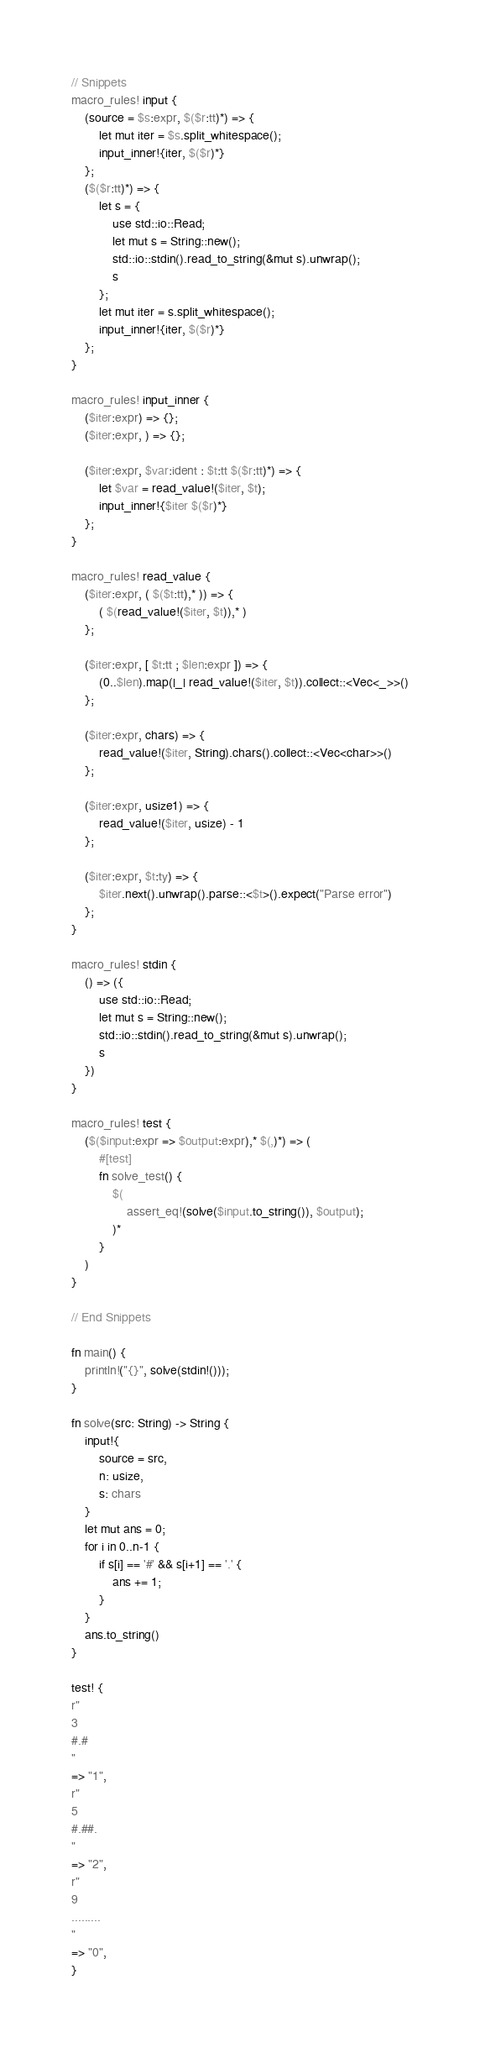Convert code to text. <code><loc_0><loc_0><loc_500><loc_500><_Rust_>// Snippets
macro_rules! input {
    (source = $s:expr, $($r:tt)*) => {
        let mut iter = $s.split_whitespace();
        input_inner!{iter, $($r)*}
    };
    ($($r:tt)*) => {
        let s = {
            use std::io::Read;
            let mut s = String::new();
            std::io::stdin().read_to_string(&mut s).unwrap();
            s
        };
        let mut iter = s.split_whitespace();
        input_inner!{iter, $($r)*}
    };
}

macro_rules! input_inner {
    ($iter:expr) => {};
    ($iter:expr, ) => {};

    ($iter:expr, $var:ident : $t:tt $($r:tt)*) => {
        let $var = read_value!($iter, $t);
        input_inner!{$iter $($r)*}
    };
}

macro_rules! read_value {
    ($iter:expr, ( $($t:tt),* )) => {
        ( $(read_value!($iter, $t)),* )
    };

    ($iter:expr, [ $t:tt ; $len:expr ]) => {
        (0..$len).map(|_| read_value!($iter, $t)).collect::<Vec<_>>()
    };

    ($iter:expr, chars) => {
        read_value!($iter, String).chars().collect::<Vec<char>>()
    };

    ($iter:expr, usize1) => {
        read_value!($iter, usize) - 1
    };

    ($iter:expr, $t:ty) => {
        $iter.next().unwrap().parse::<$t>().expect("Parse error")
    };
}

macro_rules! stdin {
    () => ({
        use std::io::Read;
        let mut s = String::new();
        std::io::stdin().read_to_string(&mut s).unwrap();
        s
    })
}

macro_rules! test {
    ($($input:expr => $output:expr),* $(,)*) => (
        #[test]
        fn solve_test() {
            $(
                assert_eq!(solve($input.to_string()), $output);
            )*
        }
    )
}

// End Snippets

fn main() {
    println!("{}", solve(stdin!()));
}

fn solve(src: String) -> String {
    input!{
        source = src,
        n: usize,
        s: chars
    }
    let mut ans = 0;
    for i in 0..n-1 {
        if s[i] == '#' && s[i+1] == '.' {
            ans += 1;
        }
    }
    ans.to_string()
}

test! {
r"
3
#.#
"
=> "1",
r"
5
#.##.
"
=> "2",
r"
9
.........
"
=> "0",
}
</code> 